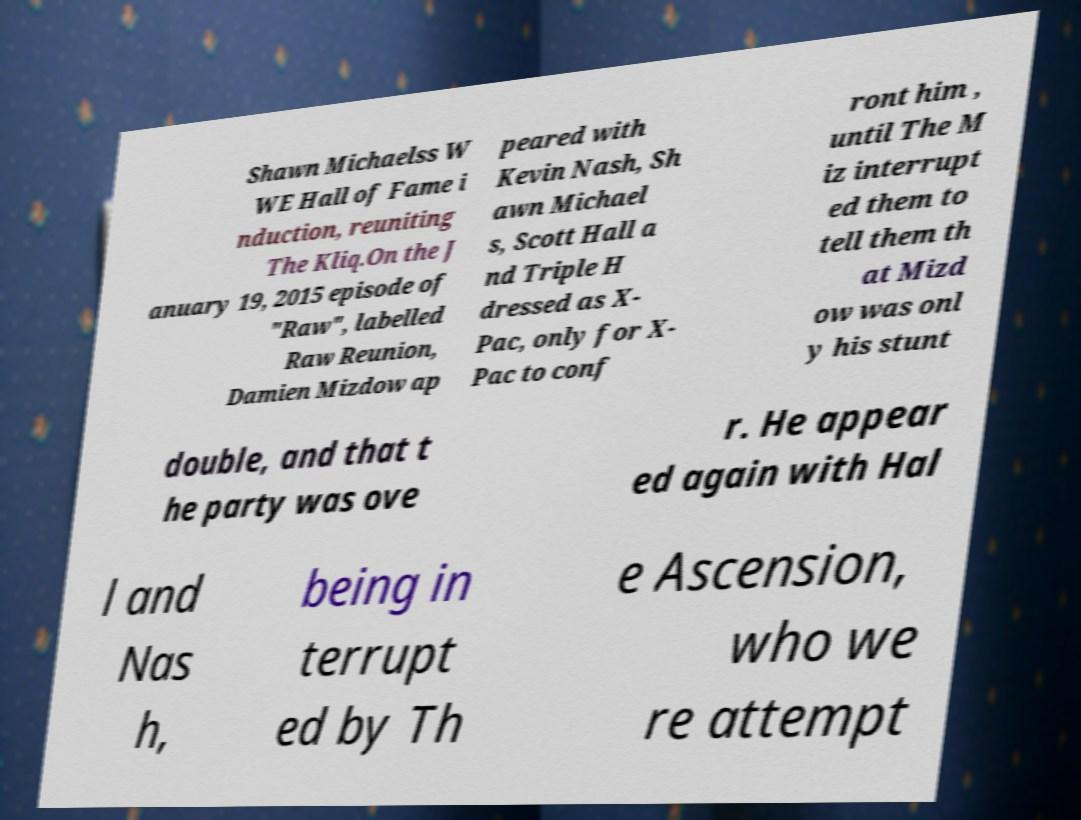Could you extract and type out the text from this image? Shawn Michaelss W WE Hall of Fame i nduction, reuniting The Kliq.On the J anuary 19, 2015 episode of "Raw", labelled Raw Reunion, Damien Mizdow ap peared with Kevin Nash, Sh awn Michael s, Scott Hall a nd Triple H dressed as X- Pac, only for X- Pac to conf ront him , until The M iz interrupt ed them to tell them th at Mizd ow was onl y his stunt double, and that t he party was ove r. He appear ed again with Hal l and Nas h, being in terrupt ed by Th e Ascension, who we re attempt 